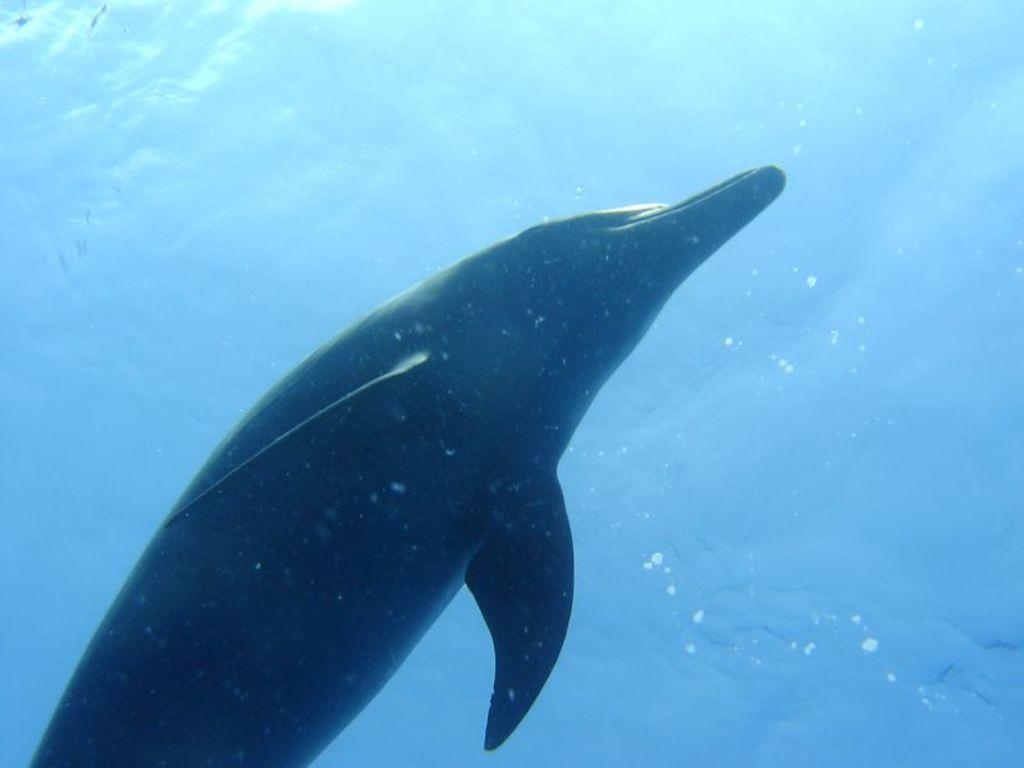What animal is in the image? There is a dolphin in the image. Where is the dolphin located? The dolphin is in the water. Who is the owner of the dolphin in the image? There is no owner mentioned or implied in the image, as dolphins are wild animals and not owned by humans. 